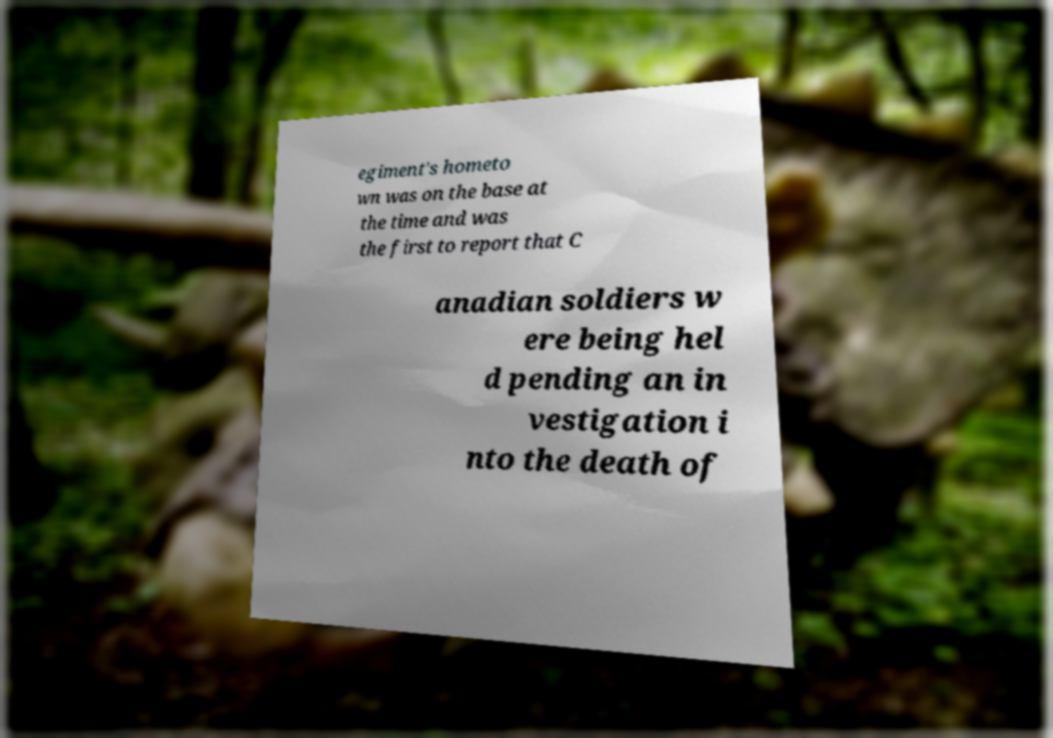Please identify and transcribe the text found in this image. egiment's hometo wn was on the base at the time and was the first to report that C anadian soldiers w ere being hel d pending an in vestigation i nto the death of 